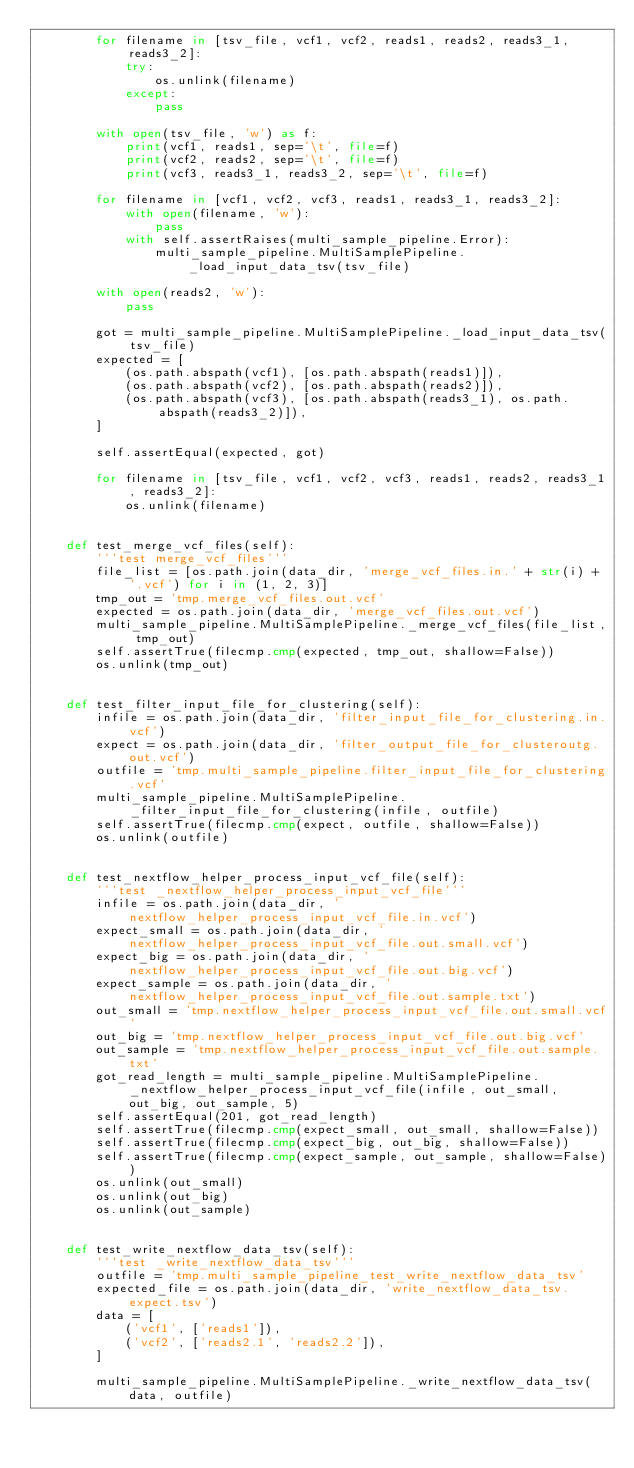<code> <loc_0><loc_0><loc_500><loc_500><_Python_>        for filename in [tsv_file, vcf1, vcf2, reads1, reads2, reads3_1, reads3_2]:
            try:
                os.unlink(filename)
            except:
                pass

        with open(tsv_file, 'w') as f:
            print(vcf1, reads1, sep='\t', file=f)
            print(vcf2, reads2, sep='\t', file=f)
            print(vcf3, reads3_1, reads3_2, sep='\t', file=f)

        for filename in [vcf1, vcf2, vcf3, reads1, reads3_1, reads3_2]:
            with open(filename, 'w'):
                pass
            with self.assertRaises(multi_sample_pipeline.Error):
                multi_sample_pipeline.MultiSamplePipeline._load_input_data_tsv(tsv_file)

        with open(reads2, 'w'):
            pass

        got = multi_sample_pipeline.MultiSamplePipeline._load_input_data_tsv(tsv_file)
        expected = [
            (os.path.abspath(vcf1), [os.path.abspath(reads1)]),
            (os.path.abspath(vcf2), [os.path.abspath(reads2)]),
            (os.path.abspath(vcf3), [os.path.abspath(reads3_1), os.path.abspath(reads3_2)]),
        ]

        self.assertEqual(expected, got)

        for filename in [tsv_file, vcf1, vcf2, vcf3, reads1, reads2, reads3_1, reads3_2]:
            os.unlink(filename)


    def test_merge_vcf_files(self):
        '''test merge_vcf_files'''
        file_list = [os.path.join(data_dir, 'merge_vcf_files.in.' + str(i) + '.vcf') for i in (1, 2, 3)]
        tmp_out = 'tmp.merge_vcf_files.out.vcf'
        expected = os.path.join(data_dir, 'merge_vcf_files.out.vcf')
        multi_sample_pipeline.MultiSamplePipeline._merge_vcf_files(file_list, tmp_out)
        self.assertTrue(filecmp.cmp(expected, tmp_out, shallow=False))
        os.unlink(tmp_out)


    def test_filter_input_file_for_clustering(self):
        infile = os.path.join(data_dir, 'filter_input_file_for_clustering.in.vcf')
        expect = os.path.join(data_dir, 'filter_output_file_for_clusteroutg.out.vcf')
        outfile = 'tmp.multi_sample_pipeline.filter_input_file_for_clustering.vcf'
        multi_sample_pipeline.MultiSamplePipeline._filter_input_file_for_clustering(infile, outfile)
        self.assertTrue(filecmp.cmp(expect, outfile, shallow=False))
        os.unlink(outfile)


    def test_nextflow_helper_process_input_vcf_file(self):
        '''test _nextflow_helper_process_input_vcf_file'''
        infile = os.path.join(data_dir, 'nextflow_helper_process_input_vcf_file.in.vcf')
        expect_small = os.path.join(data_dir, 'nextflow_helper_process_input_vcf_file.out.small.vcf')
        expect_big = os.path.join(data_dir, 'nextflow_helper_process_input_vcf_file.out.big.vcf')
        expect_sample = os.path.join(data_dir, 'nextflow_helper_process_input_vcf_file.out.sample.txt')
        out_small = 'tmp.nextflow_helper_process_input_vcf_file.out.small.vcf'
        out_big = 'tmp.nextflow_helper_process_input_vcf_file.out.big.vcf'
        out_sample = 'tmp.nextflow_helper_process_input_vcf_file.out.sample.txt'
        got_read_length = multi_sample_pipeline.MultiSamplePipeline._nextflow_helper_process_input_vcf_file(infile, out_small, out_big, out_sample, 5)
        self.assertEqual(201, got_read_length)
        self.assertTrue(filecmp.cmp(expect_small, out_small, shallow=False))
        self.assertTrue(filecmp.cmp(expect_big, out_big, shallow=False))
        self.assertTrue(filecmp.cmp(expect_sample, out_sample, shallow=False))
        os.unlink(out_small)
        os.unlink(out_big)
        os.unlink(out_sample)


    def test_write_nextflow_data_tsv(self):
        '''test _write_nextflow_data_tsv'''
        outfile = 'tmp.multi_sample_pipeline_test_write_nextflow_data_tsv'
        expected_file = os.path.join(data_dir, 'write_nextflow_data_tsv.expect.tsv')
        data = [
            ('vcf1', ['reads1']),
            ('vcf2', ['reads2.1', 'reads2.2']),
        ]

        multi_sample_pipeline.MultiSamplePipeline._write_nextflow_data_tsv(data, outfile)</code> 